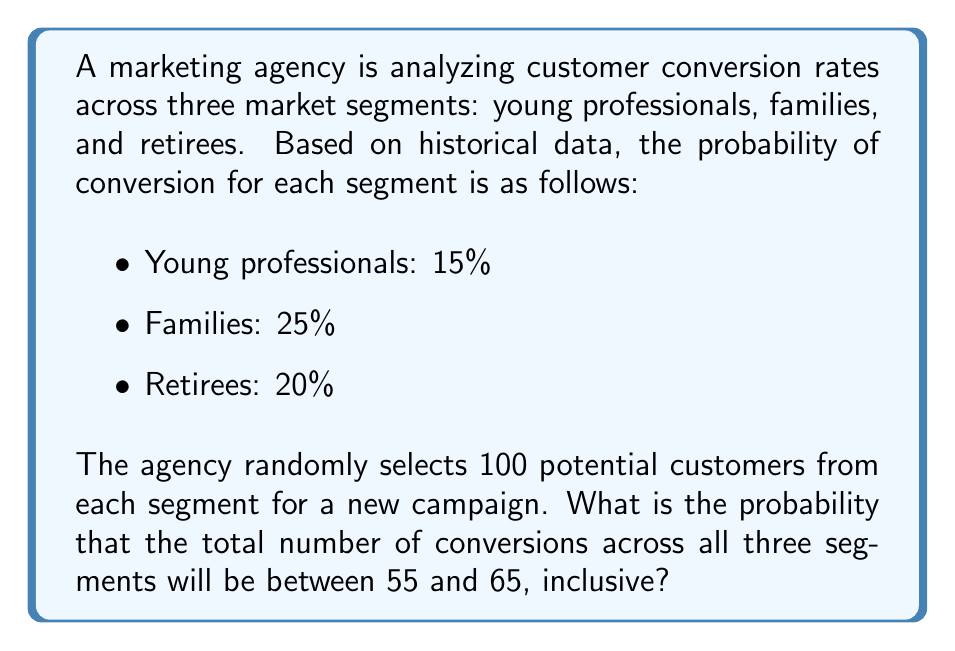Can you answer this question? To solve this problem, we'll use the following steps:

1. Recognize that this scenario follows a binomial distribution for each segment.
2. Calculate the mean and standard deviation for the total number of conversions.
3. Use the Central Limit Theorem to approximate the binomial distribution with a normal distribution.
4. Calculate the z-scores for the given range.
5. Use the standard normal distribution table or a calculator to find the probability.

Step 1: Binomial distribution
For each segment, we have a binomial distribution with n = 100 trials and p = probability of success.

Step 2: Calculate mean and standard deviation
The mean for each segment:
$$\mu_1 = 100 \times 0.15 = 15$$
$$\mu_2 = 100 \times 0.25 = 25$$
$$\mu_3 = 100 \times 0.20 = 20$$

Total mean: $$\mu_{total} = 15 + 25 + 20 = 60$$

The variance for each segment:
$$\sigma_1^2 = 100 \times 0.15 \times 0.85 = 12.75$$
$$\sigma_2^2 = 100 \times 0.25 \times 0.75 = 18.75$$
$$\sigma_3^2 = 100 \times 0.20 \times 0.80 = 16$$

Total variance: $$\sigma_{total}^2 = 12.75 + 18.75 + 16 = 47.5$$

Standard deviation: $$\sigma_{total} = \sqrt{47.5} \approx 6.89$$

Step 3: Apply Central Limit Theorem
Since we have a large number of trials (300 total), we can approximate the binomial distribution with a normal distribution.

Step 4: Calculate z-scores
For the lower bound (55):
$$z_1 = \frac{55 - 60}{6.89} \approx -0.73$$

For the upper bound (65):
$$z_2 = \frac{65 - 60}{6.89} \approx 0.73$$

Step 5: Find the probability
The probability is the area between these two z-scores on a standard normal distribution.

$$P(55 \leq X \leq 65) = P(-0.73 \leq Z \leq 0.73)$$

Using a standard normal distribution table or calculator:

$$P(-0.73 \leq Z \leq 0.73) = 0.7673 - 0.2327 = 0.5346$$
Answer: The probability that the total number of conversions across all three segments will be between 55 and 65, inclusive, is approximately 0.5346 or 53.46%. 